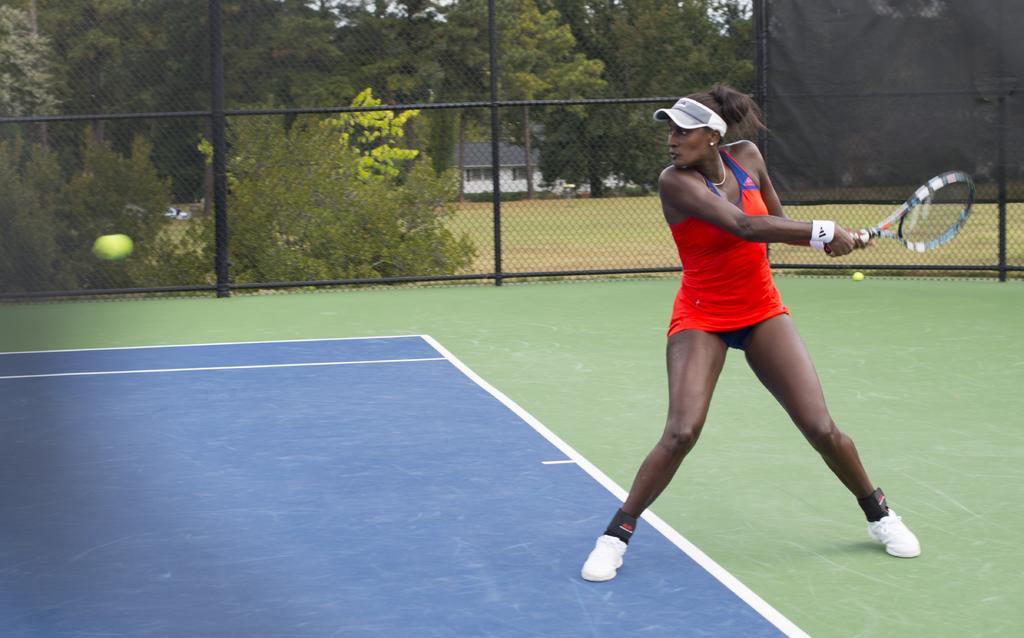Could you give a brief overview of what you see in this image? In the middle of the image a woman holding a tennis racket. In the middle of the image there is a ball. In the middle of the image there is a building. Top left side of the image there is a fencing, Through the fencing we can see some trees. Top right side of the image there is a banner. 